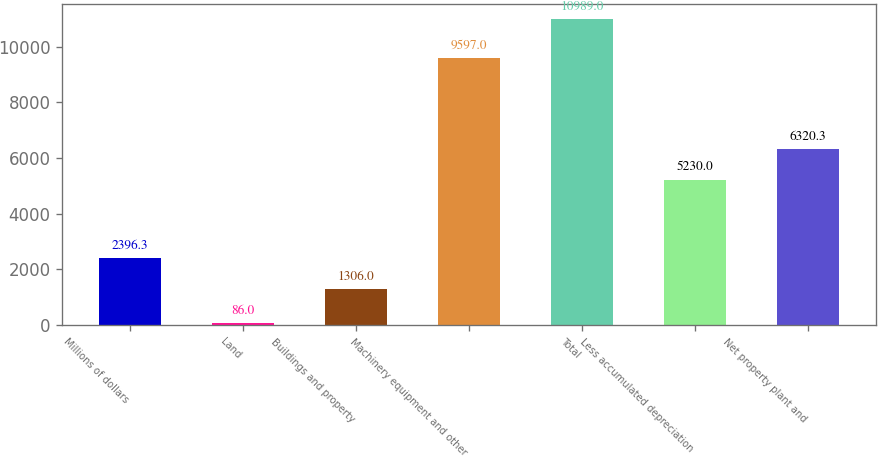Convert chart to OTSL. <chart><loc_0><loc_0><loc_500><loc_500><bar_chart><fcel>Millions of dollars<fcel>Land<fcel>Buildings and property<fcel>Machinery equipment and other<fcel>Total<fcel>Less accumulated depreciation<fcel>Net property plant and<nl><fcel>2396.3<fcel>86<fcel>1306<fcel>9597<fcel>10989<fcel>5230<fcel>6320.3<nl></chart> 